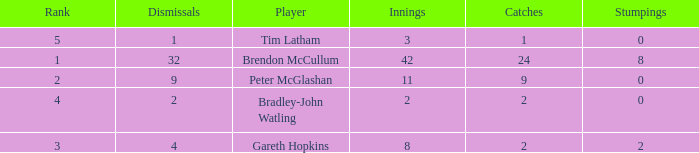Could you parse the entire table as a dict? {'header': ['Rank', 'Dismissals', 'Player', 'Innings', 'Catches', 'Stumpings'], 'rows': [['5', '1', 'Tim Latham', '3', '1', '0'], ['1', '32', 'Brendon McCullum', '42', '24', '8'], ['2', '9', 'Peter McGlashan', '11', '9', '0'], ['4', '2', 'Bradley-John Watling', '2', '2', '0'], ['3', '4', 'Gareth Hopkins', '8', '2', '2']]} List the ranks of all dismissals with a value of 4 3.0. 